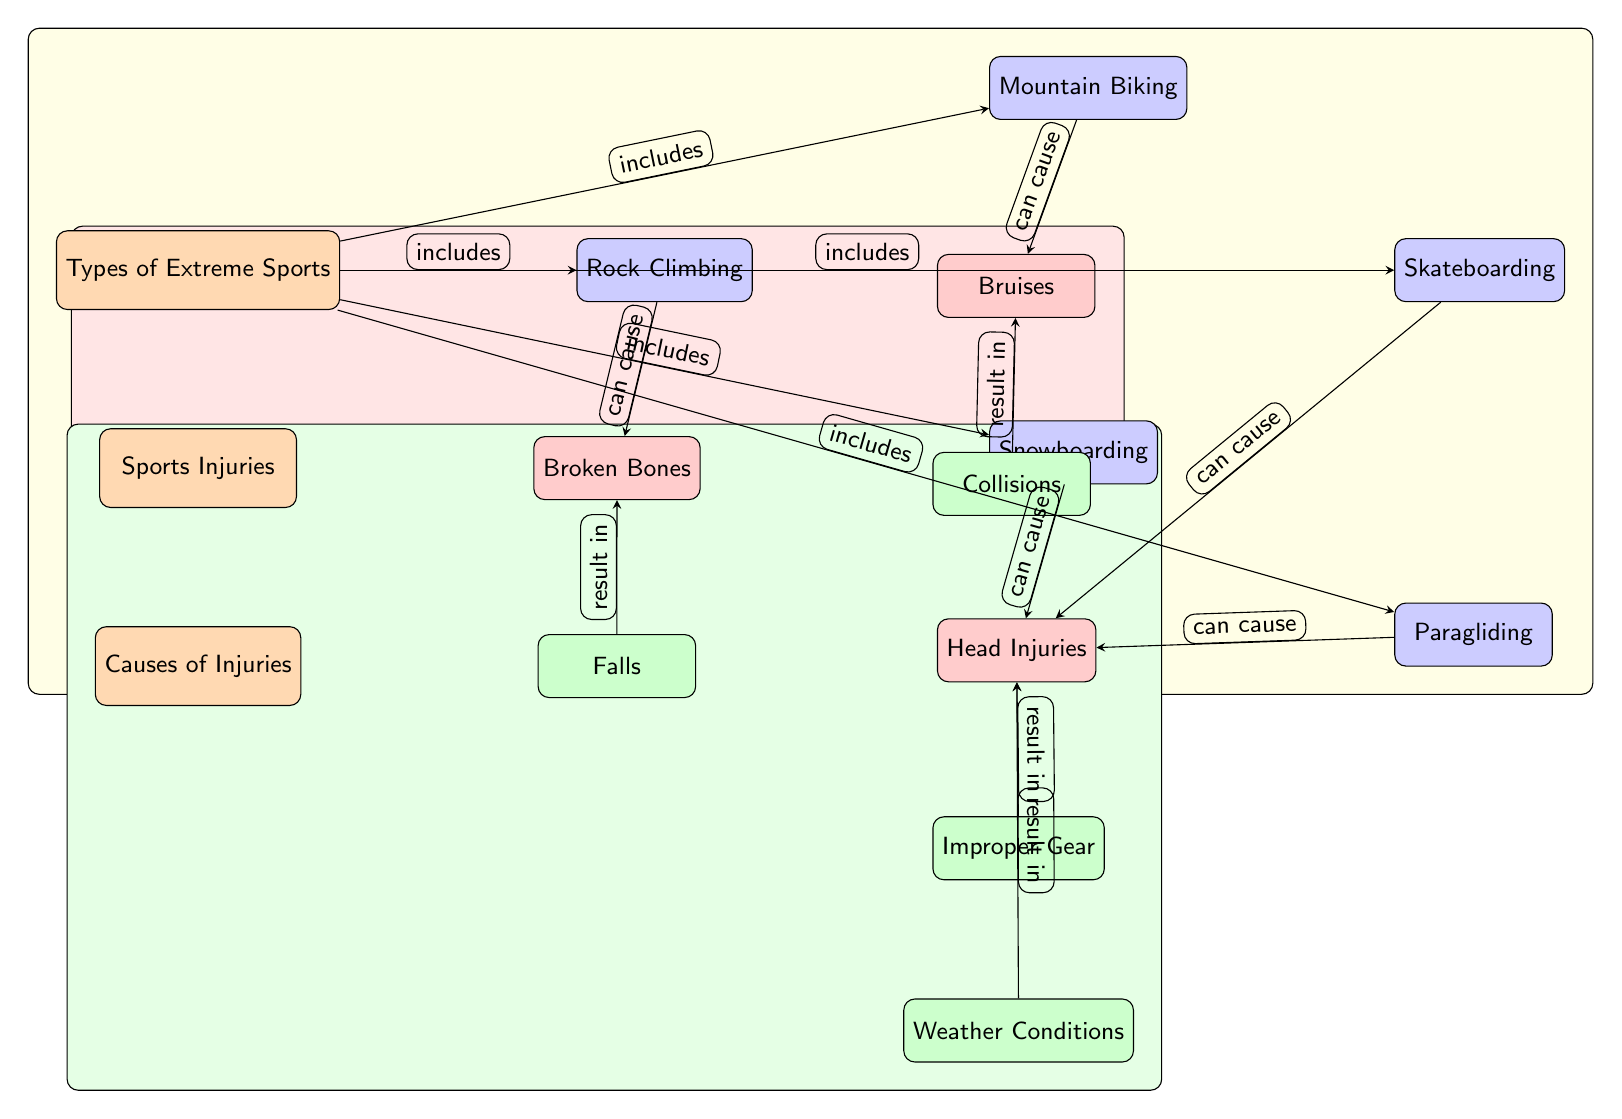What types of extreme sports are included in the diagram? The diagram lists five extreme sports: Rock Climbing, Mountain Biking, Snowboarding, Skateboarding, and Paragliding. This can be identified by following the arrows from the "Types of Extreme Sports" category node to each sport.
Answer: Rock Climbing, Mountain Biking, Snowboarding, Skateboarding, Paragliding How many types of sports injuries are represented? The diagram shows three types of sports injuries: Broken Bones, Bruises, and Head Injuries. This information is derived from the "Sports Injuries" category connected to the injury nodes.
Answer: Three Which injury is connected to more than one cause? Head Injuries are linked to multiple causes, specifically Falls, Collisions, Improper Gear, and Weather Conditions as represented by the outgoing edges from Head Injuries to these cause nodes.
Answer: Head Injuries Which extreme sport can cause broken bones? Rock Climbing is directly indicated as being able to cause Broken Bones. The connection can be traced from the Rock Climbing node to the Broken Bones node in the diagram.
Answer: Rock Climbing What is the cause associated with bruises? The diagram shows that Collisions lead to Bruises. This is evident from the direct arrow that indicates the relationship from the Collisions node to the Bruises node.
Answer: Collisions How is the relationship between Falls and Broken Bones described? The diagram describes Falls as resulting in Broken Bones, indicated by the arrow from the Falls node pointing directly to the Broken Bones node, showing a direct consequence relationship.
Answer: Results in Which types of extreme sports can cause Head Injuries? Snowboarding, Skateboarding, Rock Climbing, and Paragliding all are connected to the Head Injuries node with arrows describing their potential to cause this injury.
Answer: Snowboarding, Skateboarding, Rock Climbing, Paragliding Which causes are linked to head injuries? The causes linked to Head Injuries include Falls, Collisions, Improper Gear, and Weather Conditions. Each of these causes connects to the Head Injuries node by outgoing edges from their respective nodes.
Answer: Falls, Collisions, Improper Gear, Weather Conditions 